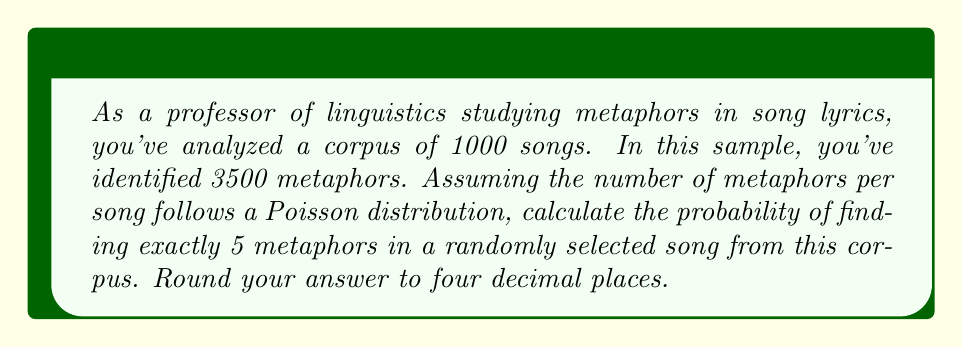Provide a solution to this math problem. To solve this problem, we need to use the Poisson distribution formula:

$$P(X = k) = \frac{e^{-\lambda} \lambda^k}{k!}$$

Where:
$P(X = k)$ is the probability of $k$ occurrences
$\lambda$ is the average number of occurrences
$e$ is Euler's number (approximately 2.71828)
$k!$ is the factorial of $k$

Step 1: Calculate $\lambda$ (average number of metaphors per song)
$$\lambda = \frac{\text{Total number of metaphors}}{\text{Total number of songs}} = \frac{3500}{1000} = 3.5$$

Step 2: Use the Poisson distribution formula with $k = 5$ and $\lambda = 3.5$

$$P(X = 5) = \frac{e^{-3.5} 3.5^5}{5!}$$

Step 3: Calculate each part:
$e^{-3.5} \approx 0.0302686$
$3.5^5 \approx 525.21875$
$5! = 120$

Step 4: Put it all together:

$$P(X = 5) = \frac{0.0302686 \times 525.21875}{120} \approx 0.1328$$

Step 5: Round to four decimal places: 0.1328
Answer: 0.1328 